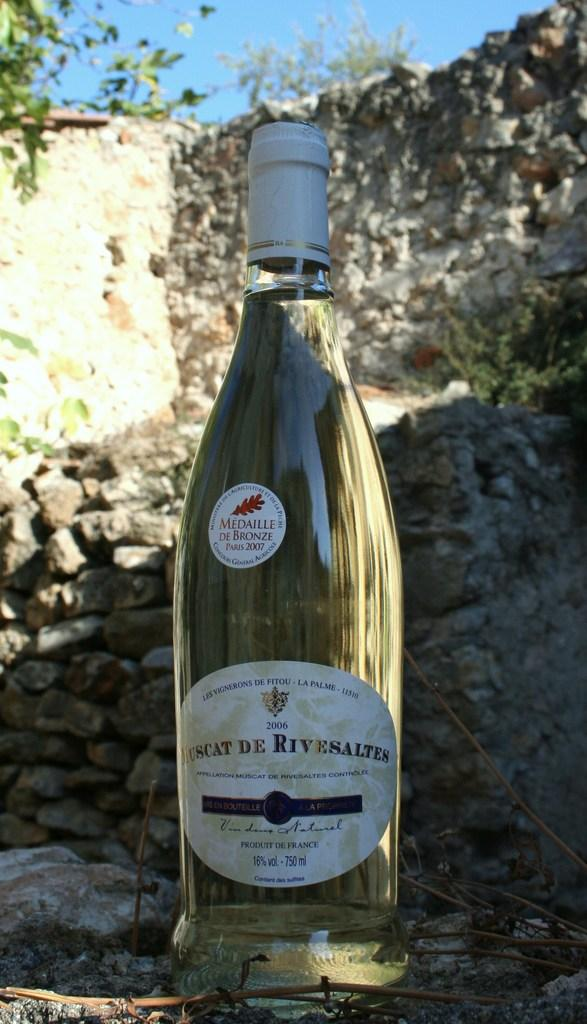<image>
Write a terse but informative summary of the picture. A bottle of wine from 2006 won a medal in 2007. 